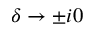Convert formula to latex. <formula><loc_0><loc_0><loc_500><loc_500>\delta \to \pm i 0</formula> 